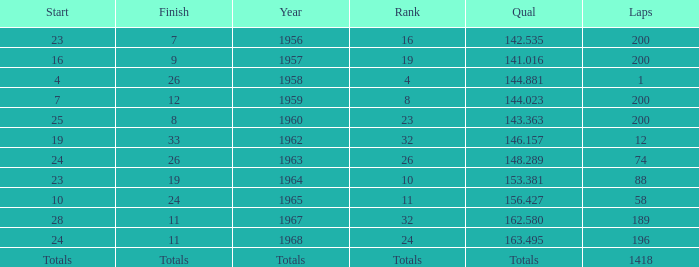Which qual has both 200 total laps and took place in 1957? 141.016. 